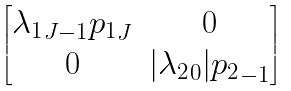<formula> <loc_0><loc_0><loc_500><loc_500>\begin{bmatrix} { \lambda _ { 1 } } _ { J - 1 } { p _ { 1 } } _ { J } & 0 \\ 0 & | { \lambda _ { 2 } } _ { 0 } | { p _ { 2 } } _ { - 1 } \end{bmatrix}</formula> 